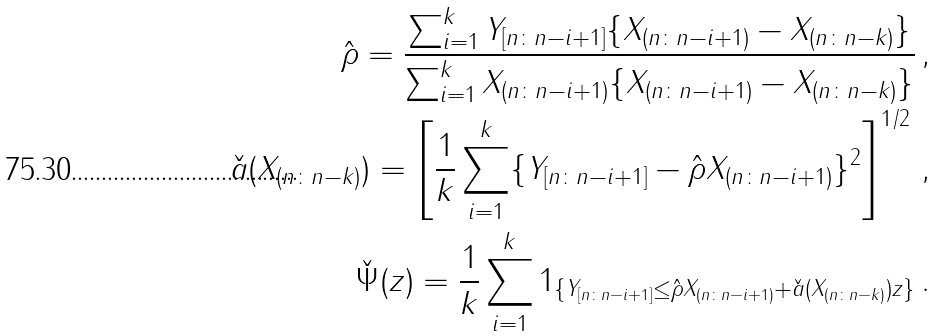<formula> <loc_0><loc_0><loc_500><loc_500>\hat { \rho } = \frac { \sum _ { i = 1 } ^ { k } Y _ { [ n \colon n - i + 1 ] } \{ X _ { ( n \colon n - i + 1 ) } - X _ { ( n \colon n - k ) } \} } { \sum _ { i = 1 } ^ { k } X _ { ( n \colon n - i + 1 ) } \{ X _ { ( n \colon n - i + 1 ) } - X _ { ( n \colon n - k ) } \} } \, , \\ \check { a } ( X _ { ( n \colon n - k ) } ) = \left [ \frac { 1 } { k } \sum _ { i = 1 } ^ { k } \{ Y _ { [ n \colon n - i + 1 ] } - \hat { \rho } X _ { ( n \colon n - i + 1 ) } \} ^ { 2 } \right ] ^ { 1 / 2 } \, , \\ \check { \Psi } ( z ) = \frac { 1 } { k } \sum _ { i = 1 } ^ { k } 1 _ { \{ Y _ { [ n \colon n - i + 1 ] } \leq \hat { \rho } X _ { ( n \colon n - i + 1 ) } + \check { a } ( X _ { ( n \colon n - k ) } ) z \} } \, .</formula> 